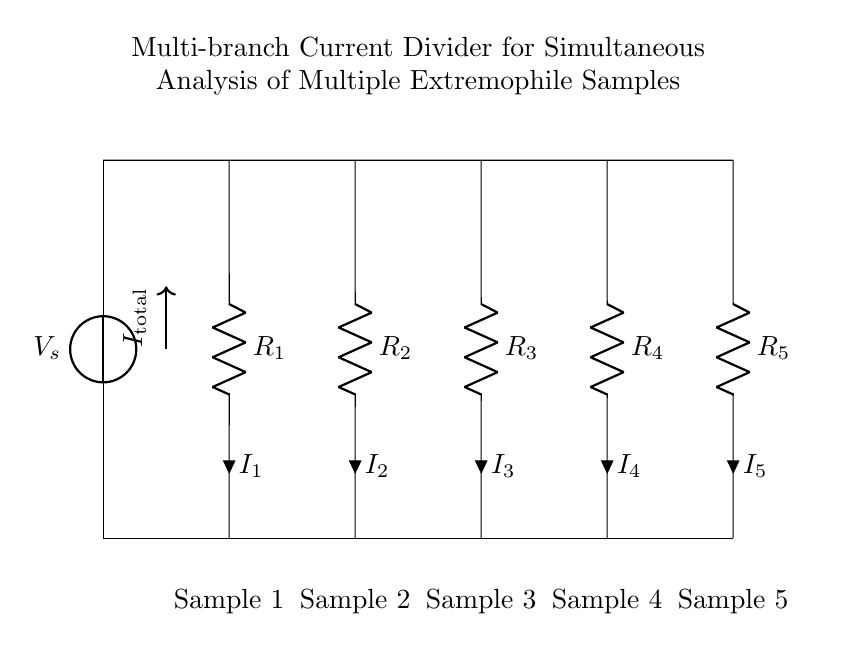What is the current flowing through Sample 3? The current flowing through Sample 3 is denoted as I3 in the circuit diagram, indicated by the label next to the resistor R3.
Answer: I3 How many resistors are used in this current divider? There are five resistors in the circuit, labeled R1, R2, R3, R4, and R5.
Answer: Five What is the total current entering the circuit? The total current entering the circuit is represented by I_total, indicated by the arrow pointing into the circuit at the source connection.
Answer: I_total Which sample has the highest resistance? To determine which sample has the highest resistance, one would observe the resistance values of the resistors connected to each sample. Without specific values, we can't conclude. If there are no specific values given, it's typical to assume if all resistors are equal, they are the same. Thus, the answer would be that no single sample stands out as having a specific highest resistance.
Answer: Cannot determine What is the purpose of the current divider in this circuit? The purpose of the current divider in this configuration is to allow for simultaneous analysis of multiple extremophile samples, with each sample receiving a fraction of the total current based on its resistance.
Answer: Simultaneous analysis of samples What happens to the current if one resistor fails? If one resistor fails (opens), the current to that sample becomes zero, while the total current will redistribute among the remaining resistors according to their resistance values, impacting the current measurements for the other samples.
Answer: Current to that sample becomes zero What is the configuration type of this circuit? The configuration of the circuit is a parallel circuit as all resistors are connected across the same voltage source and each subsequent branch carries a portion of the total current.
Answer: Parallel circuit 